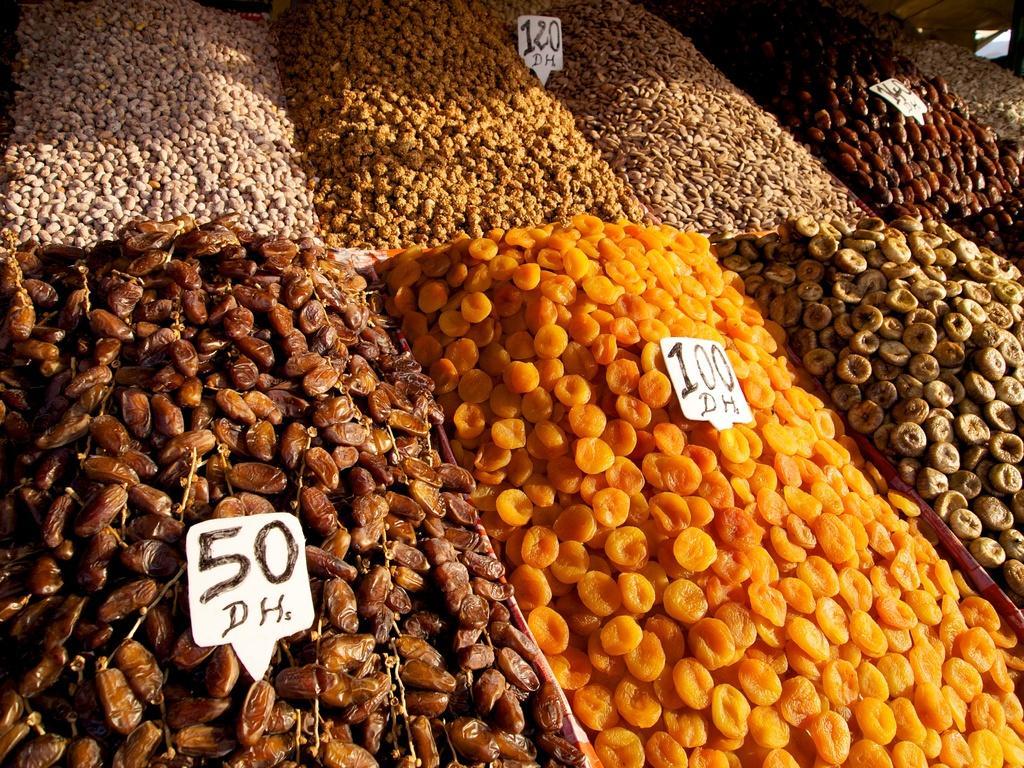Describe this image in one or two sentences. In this image there are a different types of dry fruits are there as we can see in the middle of this image, and there are some rare birds are kept on it. 